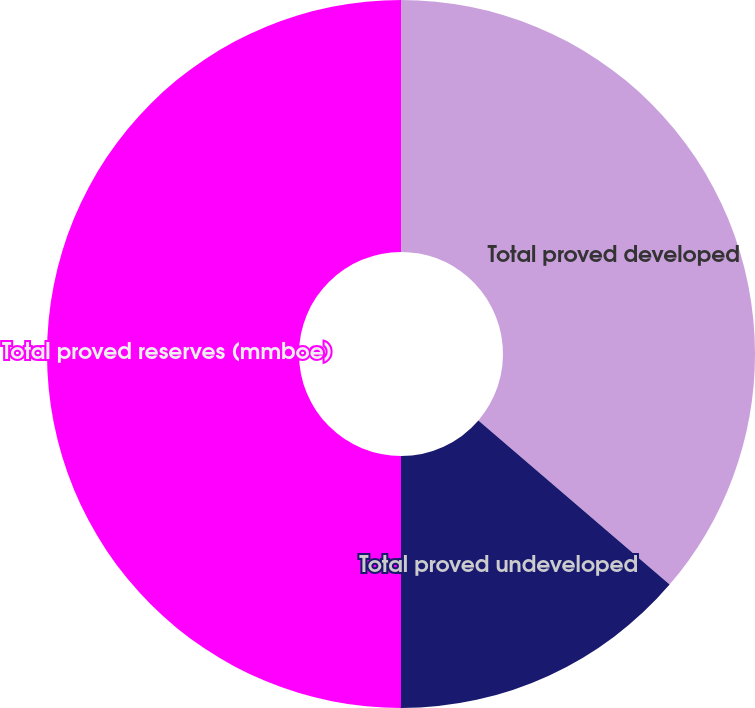Convert chart to OTSL. <chart><loc_0><loc_0><loc_500><loc_500><pie_chart><fcel>Total proved developed<fcel>Total proved undeveloped<fcel>Total proved reserves (mmboe)<nl><fcel>36.29%<fcel>13.71%<fcel>50.0%<nl></chart> 